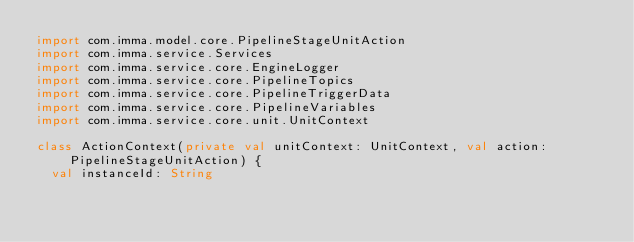Convert code to text. <code><loc_0><loc_0><loc_500><loc_500><_Kotlin_>import com.imma.model.core.PipelineStageUnitAction
import com.imma.service.Services
import com.imma.service.core.EngineLogger
import com.imma.service.core.PipelineTopics
import com.imma.service.core.PipelineTriggerData
import com.imma.service.core.PipelineVariables
import com.imma.service.core.unit.UnitContext

class ActionContext(private val unitContext: UnitContext, val action: PipelineStageUnitAction) {
	val instanceId: String</code> 